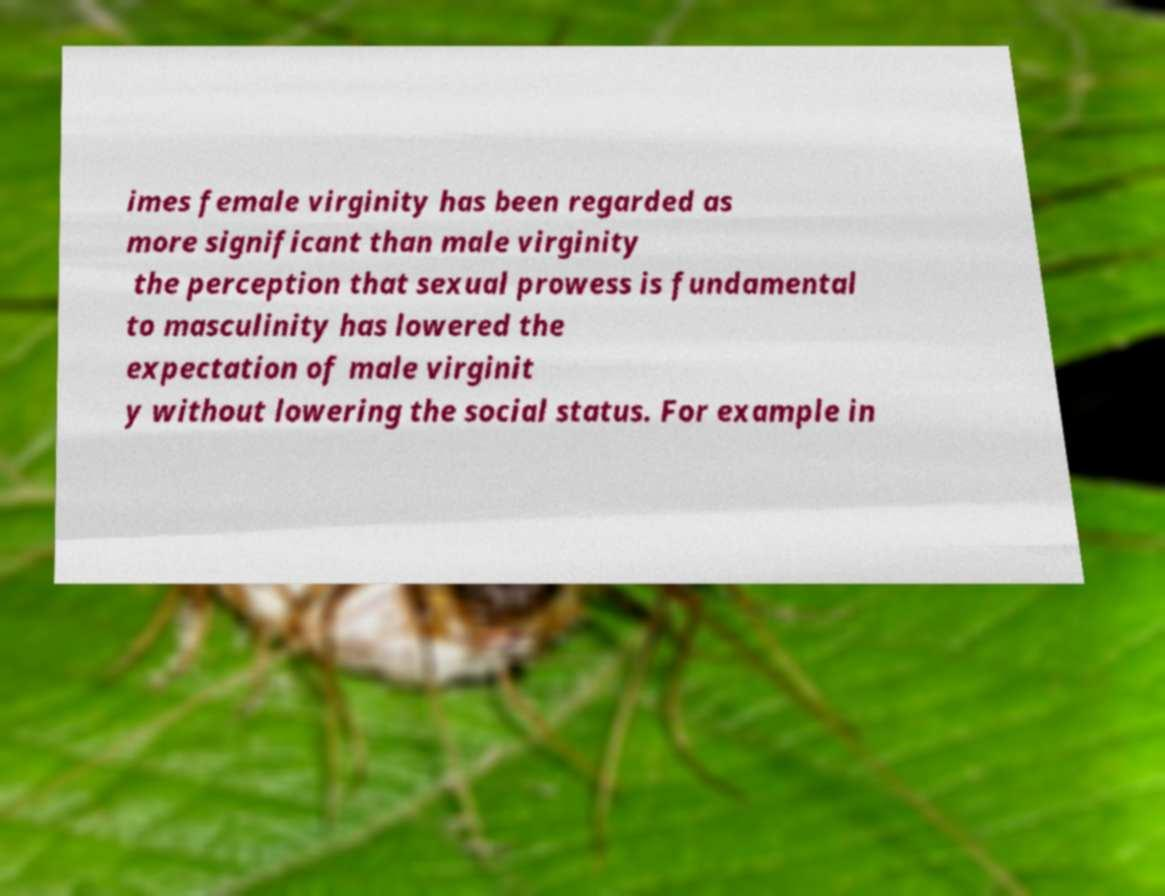Can you accurately transcribe the text from the provided image for me? imes female virginity has been regarded as more significant than male virginity the perception that sexual prowess is fundamental to masculinity has lowered the expectation of male virginit y without lowering the social status. For example in 